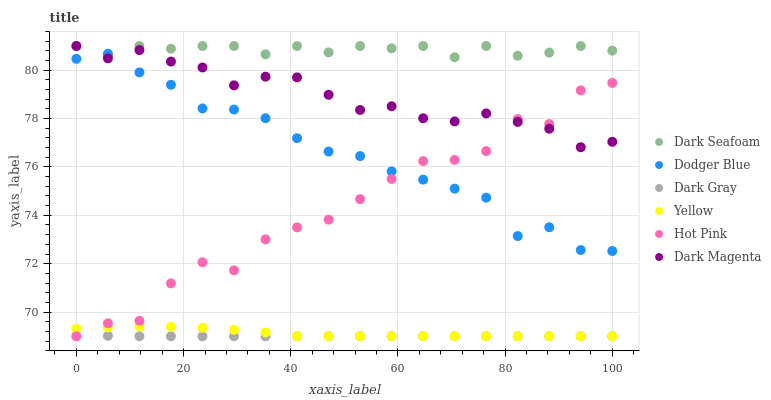Does Dark Gray have the minimum area under the curve?
Answer yes or no. Yes. Does Dark Seafoam have the maximum area under the curve?
Answer yes or no. Yes. Does Hot Pink have the minimum area under the curve?
Answer yes or no. No. Does Hot Pink have the maximum area under the curve?
Answer yes or no. No. Is Dark Gray the smoothest?
Answer yes or no. Yes. Is Hot Pink the roughest?
Answer yes or no. Yes. Is Yellow the smoothest?
Answer yes or no. No. Is Yellow the roughest?
Answer yes or no. No. Does Hot Pink have the lowest value?
Answer yes or no. Yes. Does Dark Seafoam have the lowest value?
Answer yes or no. No. Does Dark Seafoam have the highest value?
Answer yes or no. Yes. Does Hot Pink have the highest value?
Answer yes or no. No. Is Yellow less than Dodger Blue?
Answer yes or no. Yes. Is Dark Seafoam greater than Hot Pink?
Answer yes or no. Yes. Does Yellow intersect Dark Gray?
Answer yes or no. Yes. Is Yellow less than Dark Gray?
Answer yes or no. No. Is Yellow greater than Dark Gray?
Answer yes or no. No. Does Yellow intersect Dodger Blue?
Answer yes or no. No. 